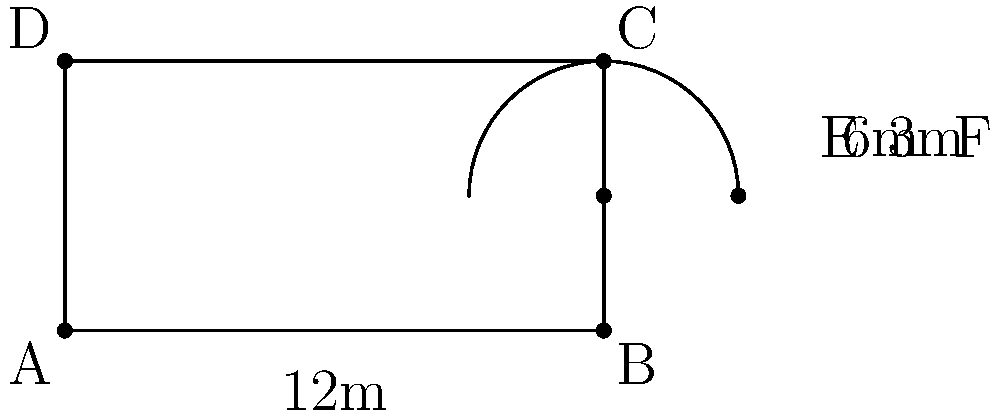A smart stable design includes a rectangular area for horses and an attached semicircular run for exercise. The rectangular stable measures 12m by 6m, with the semicircular run extending from one of the longer sides. If the radius of the semicircular run is half the width of the stable, what is the total perimeter of this innovative horse enclosure? Let's approach this step-by-step:

1) First, let's identify the known dimensions:
   - Length of rectangle: 12m
   - Width of rectangle: 6m
   - Radius of semicircle: 6m ÷ 2 = 3m

2) Calculate the perimeter of the rectangle:
   $$P_{rectangle} = 2(l + w) = 2(12 + 6) = 2(18) = 36m$$

3) Calculate the length of the semicircle:
   The formula for the length of a semicircle is $\pi r$
   $$L_{semicircle} = \pi r = \pi \times 3 = 3\pi m$$

4) To get the total perimeter, we need to:
   - Add the perimeter of the rectangle
   - Subtract the length of one long side of the rectangle (as it's replaced by the semicircle)
   - Add the length of the semicircle

5) Put it all together:
   $$P_{total} = P_{rectangle} - 12m + L_{semicircle}$$
   $$P_{total} = 36m - 12m + 3\pi m$$
   $$P_{total} = 24m + 3\pi m$$

6) Simplify:
   $$P_{total} = 24 + 3\pi m \approx 33.42m$$
Answer: $24 + 3\pi$ meters 